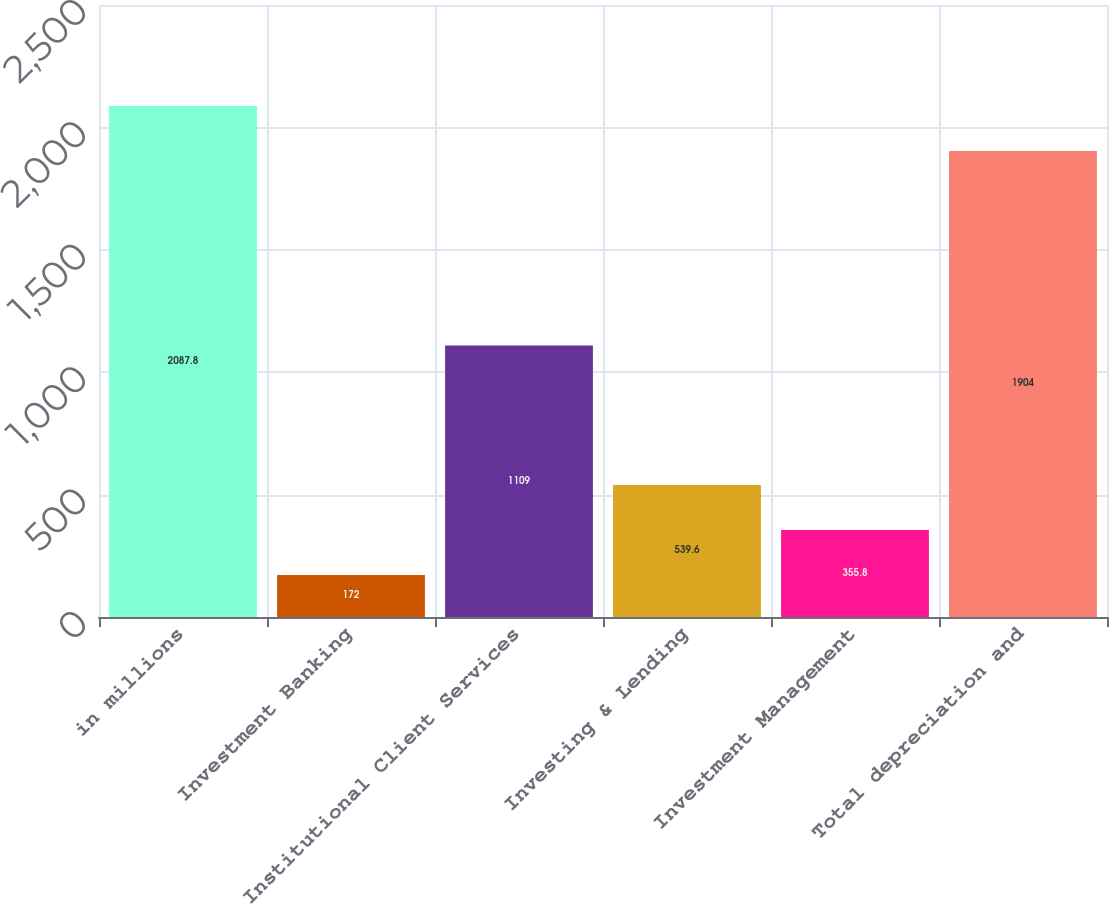Convert chart to OTSL. <chart><loc_0><loc_0><loc_500><loc_500><bar_chart><fcel>in millions<fcel>Investment Banking<fcel>Institutional Client Services<fcel>Investing & Lending<fcel>Investment Management<fcel>Total depreciation and<nl><fcel>2087.8<fcel>172<fcel>1109<fcel>539.6<fcel>355.8<fcel>1904<nl></chart> 